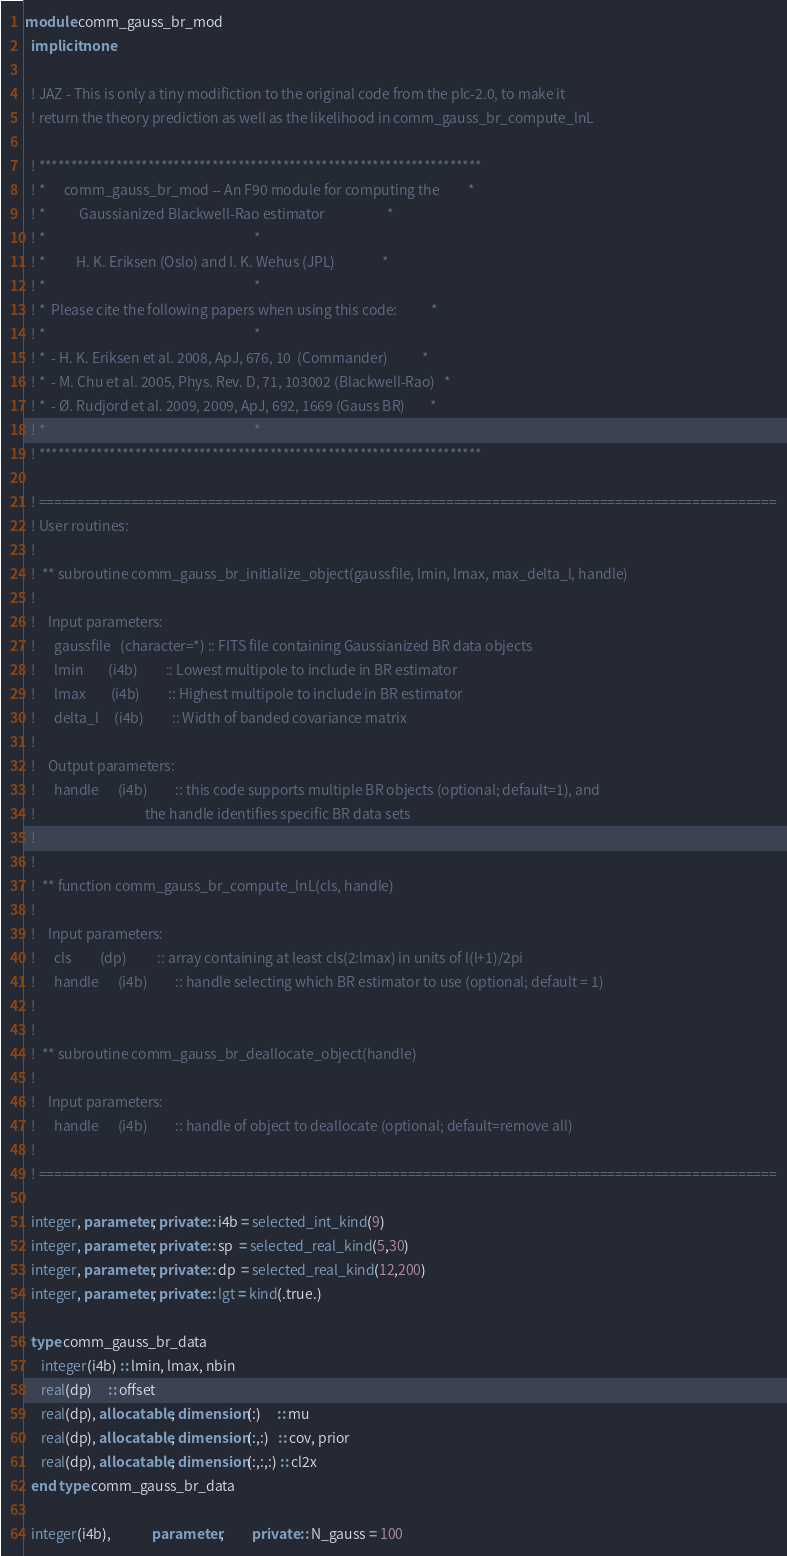Convert code to text. <code><loc_0><loc_0><loc_500><loc_500><_FORTRAN_>module comm_gauss_br_mod
  implicit none

  ! JAZ - This is only a tiny modifiction to the original code from the plc-2.0, to make it
  ! return the theory prediction as well as the likelihood in comm_gauss_br_compute_lnL

  ! *********************************************************************
  ! *      comm_gauss_br_mod -- An F90 module for computing the         *
  ! *           Gaussianized Blackwell-Rao estimator                    *
  ! *                                                                   *
  ! *          H. K. Eriksen (Oslo) and I. K. Wehus (JPL)               *
  ! *                                                                   *
  ! *  Please cite the following papers when using this code:           *
  ! *                                                                   *
  ! *  - H. K. Eriksen et al. 2008, ApJ, 676, 10  (Commander)           *
  ! *  - M. Chu et al. 2005, Phys. Rev. D, 71, 103002 (Blackwell-Rao)   *
  ! *  - Ø. Rudjord et al. 2009, 2009, ApJ, 692, 1669 (Gauss BR)        *
  ! *                                                                   *
  ! *********************************************************************

  ! ================================================================================================
  ! User routines:
  !
  !  ** subroutine comm_gauss_br_initialize_object(gaussfile, lmin, lmax, max_delta_l, handle)
  !
  !    Input parameters:
  !      gaussfile   (character=*) :: FITS file containing Gaussianized BR data objects
  !      lmin        (i4b)         :: Lowest multipole to include in BR estimator
  !      lmax        (i4b)         :: Highest multipole to include in BR estimator
  !      delta_l     (i4b)         :: Width of banded covariance matrix
  ! 
  !    Output parameters:
  !      handle      (i4b)         :: this code supports multiple BR objects (optional; default=1), and
  !                                   the handle identifies specific BR data sets
  !
  ! 
  !  ** function comm_gauss_br_compute_lnL(cls, handle)
  !
  !    Input parameters:
  !      cls         (dp)          :: array containing at least cls(2:lmax) in units of l(l+1)/2pi
  !      handle      (i4b)         :: handle selecting which BR estimator to use (optional; default = 1)
  !    
  !  
  !  ** subroutine comm_gauss_br_deallocate_object(handle)
  ! 
  !    Input parameters:
  !      handle      (i4b)         :: handle of object to deallocate (optional; default=remove all)
  !
  ! ================================================================================================

  integer, parameter, private :: i4b = selected_int_kind(9)
  integer, parameter, private :: sp  = selected_real_kind(5,30)
  integer, parameter, private :: dp  = selected_real_kind(12,200)
  integer, parameter, private :: lgt = kind(.true.)

  type comm_gauss_br_data
     integer(i4b) :: lmin, lmax, nbin
     real(dp)     :: offset
     real(dp), allocatable, dimension(:)     :: mu
     real(dp), allocatable, dimension(:,:)   :: cov, prior
     real(dp), allocatable, dimension(:,:,:) :: cl2x
  end type comm_gauss_br_data

  integer(i4b),             parameter,         private :: N_gauss = 100</code> 